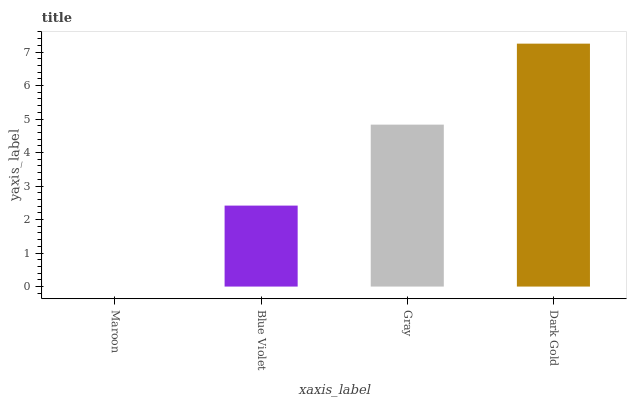Is Blue Violet the minimum?
Answer yes or no. No. Is Blue Violet the maximum?
Answer yes or no. No. Is Blue Violet greater than Maroon?
Answer yes or no. Yes. Is Maroon less than Blue Violet?
Answer yes or no. Yes. Is Maroon greater than Blue Violet?
Answer yes or no. No. Is Blue Violet less than Maroon?
Answer yes or no. No. Is Gray the high median?
Answer yes or no. Yes. Is Blue Violet the low median?
Answer yes or no. Yes. Is Maroon the high median?
Answer yes or no. No. Is Gray the low median?
Answer yes or no. No. 